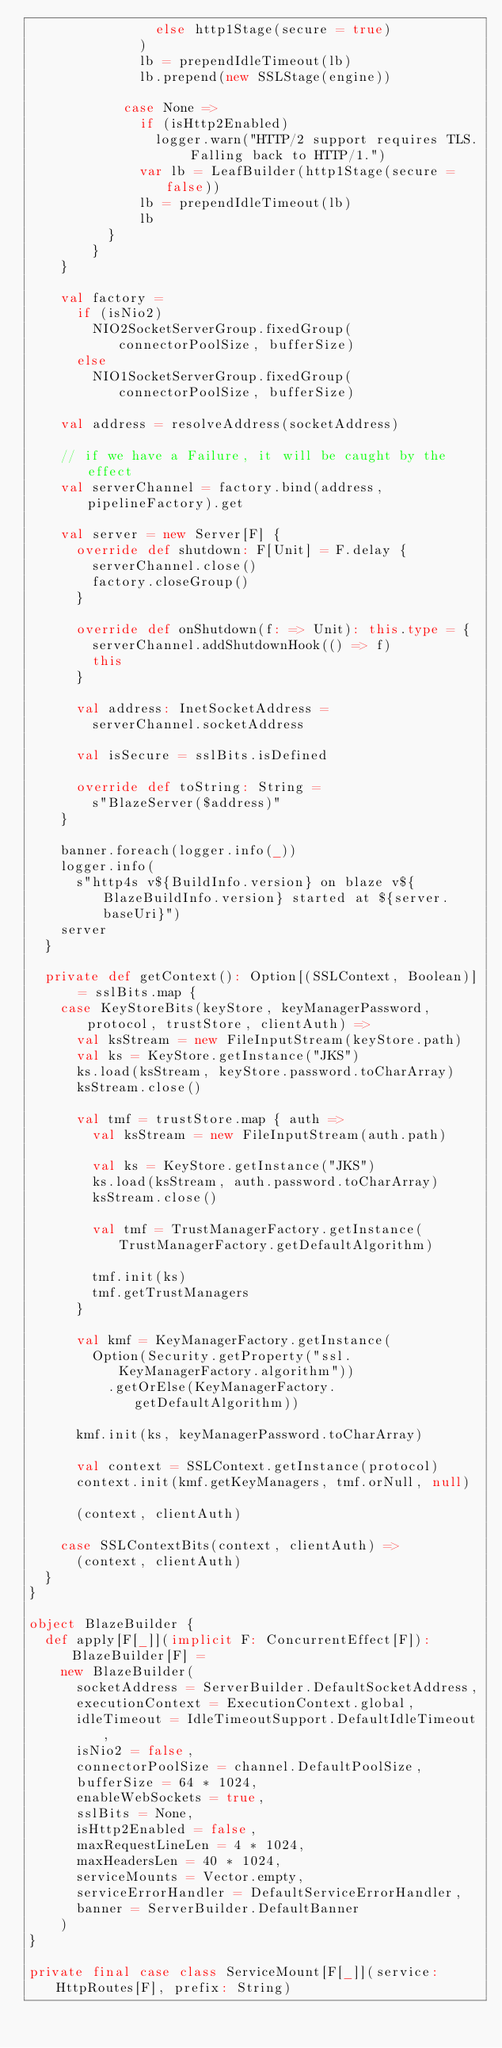<code> <loc_0><loc_0><loc_500><loc_500><_Scala_>                else http1Stage(secure = true)
              )
              lb = prependIdleTimeout(lb)
              lb.prepend(new SSLStage(engine))

            case None =>
              if (isHttp2Enabled)
                logger.warn("HTTP/2 support requires TLS. Falling back to HTTP/1.")
              var lb = LeafBuilder(http1Stage(secure = false))
              lb = prependIdleTimeout(lb)
              lb
          }
        }
    }

    val factory =
      if (isNio2)
        NIO2SocketServerGroup.fixedGroup(connectorPoolSize, bufferSize)
      else
        NIO1SocketServerGroup.fixedGroup(connectorPoolSize, bufferSize)

    val address = resolveAddress(socketAddress)

    // if we have a Failure, it will be caught by the effect
    val serverChannel = factory.bind(address, pipelineFactory).get

    val server = new Server[F] {
      override def shutdown: F[Unit] = F.delay {
        serverChannel.close()
        factory.closeGroup()
      }

      override def onShutdown(f: => Unit): this.type = {
        serverChannel.addShutdownHook(() => f)
        this
      }

      val address: InetSocketAddress =
        serverChannel.socketAddress

      val isSecure = sslBits.isDefined

      override def toString: String =
        s"BlazeServer($address)"
    }

    banner.foreach(logger.info(_))
    logger.info(
      s"http4s v${BuildInfo.version} on blaze v${BlazeBuildInfo.version} started at ${server.baseUri}")
    server
  }

  private def getContext(): Option[(SSLContext, Boolean)] = sslBits.map {
    case KeyStoreBits(keyStore, keyManagerPassword, protocol, trustStore, clientAuth) =>
      val ksStream = new FileInputStream(keyStore.path)
      val ks = KeyStore.getInstance("JKS")
      ks.load(ksStream, keyStore.password.toCharArray)
      ksStream.close()

      val tmf = trustStore.map { auth =>
        val ksStream = new FileInputStream(auth.path)

        val ks = KeyStore.getInstance("JKS")
        ks.load(ksStream, auth.password.toCharArray)
        ksStream.close()

        val tmf = TrustManagerFactory.getInstance(TrustManagerFactory.getDefaultAlgorithm)

        tmf.init(ks)
        tmf.getTrustManagers
      }

      val kmf = KeyManagerFactory.getInstance(
        Option(Security.getProperty("ssl.KeyManagerFactory.algorithm"))
          .getOrElse(KeyManagerFactory.getDefaultAlgorithm))

      kmf.init(ks, keyManagerPassword.toCharArray)

      val context = SSLContext.getInstance(protocol)
      context.init(kmf.getKeyManagers, tmf.orNull, null)

      (context, clientAuth)

    case SSLContextBits(context, clientAuth) =>
      (context, clientAuth)
  }
}

object BlazeBuilder {
  def apply[F[_]](implicit F: ConcurrentEffect[F]): BlazeBuilder[F] =
    new BlazeBuilder(
      socketAddress = ServerBuilder.DefaultSocketAddress,
      executionContext = ExecutionContext.global,
      idleTimeout = IdleTimeoutSupport.DefaultIdleTimeout,
      isNio2 = false,
      connectorPoolSize = channel.DefaultPoolSize,
      bufferSize = 64 * 1024,
      enableWebSockets = true,
      sslBits = None,
      isHttp2Enabled = false,
      maxRequestLineLen = 4 * 1024,
      maxHeadersLen = 40 * 1024,
      serviceMounts = Vector.empty,
      serviceErrorHandler = DefaultServiceErrorHandler,
      banner = ServerBuilder.DefaultBanner
    )
}

private final case class ServiceMount[F[_]](service: HttpRoutes[F], prefix: String)
</code> 